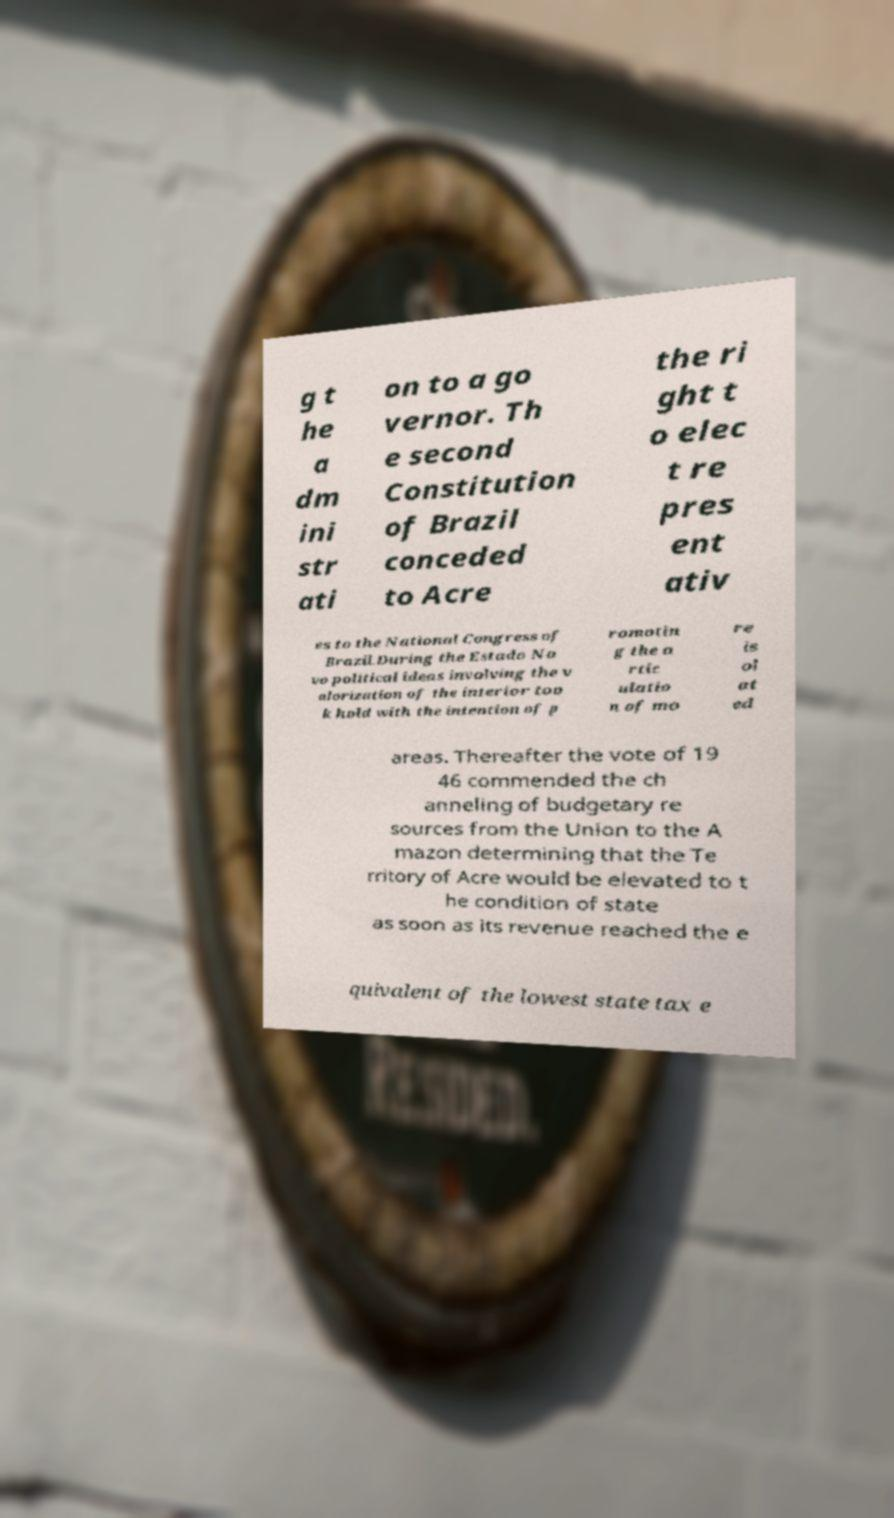There's text embedded in this image that I need extracted. Can you transcribe it verbatim? g t he a dm ini str ati on to a go vernor. Th e second Constitution of Brazil conceded to Acre the ri ght t o elec t re pres ent ativ es to the National Congress of Brazil.During the Estado No vo political ideas involving the v alorization of the interior too k hold with the intention of p romotin g the a rtic ulatio n of mo re is ol at ed areas. Thereafter the vote of 19 46 commended the ch anneling of budgetary re sources from the Union to the A mazon determining that the Te rritory of Acre would be elevated to t he condition of state as soon as its revenue reached the e quivalent of the lowest state tax e 